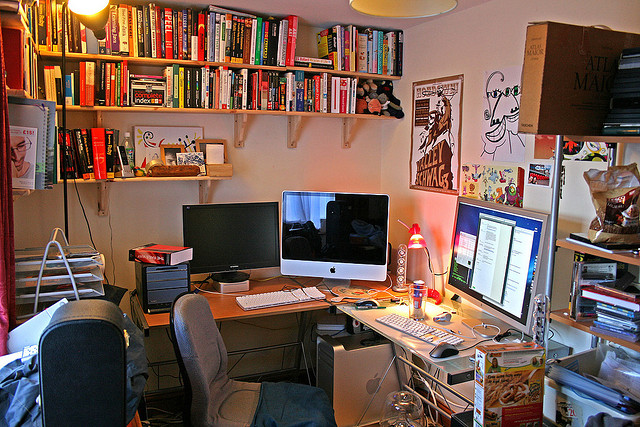Read and extract the text from this image. VALLEY PEEL 